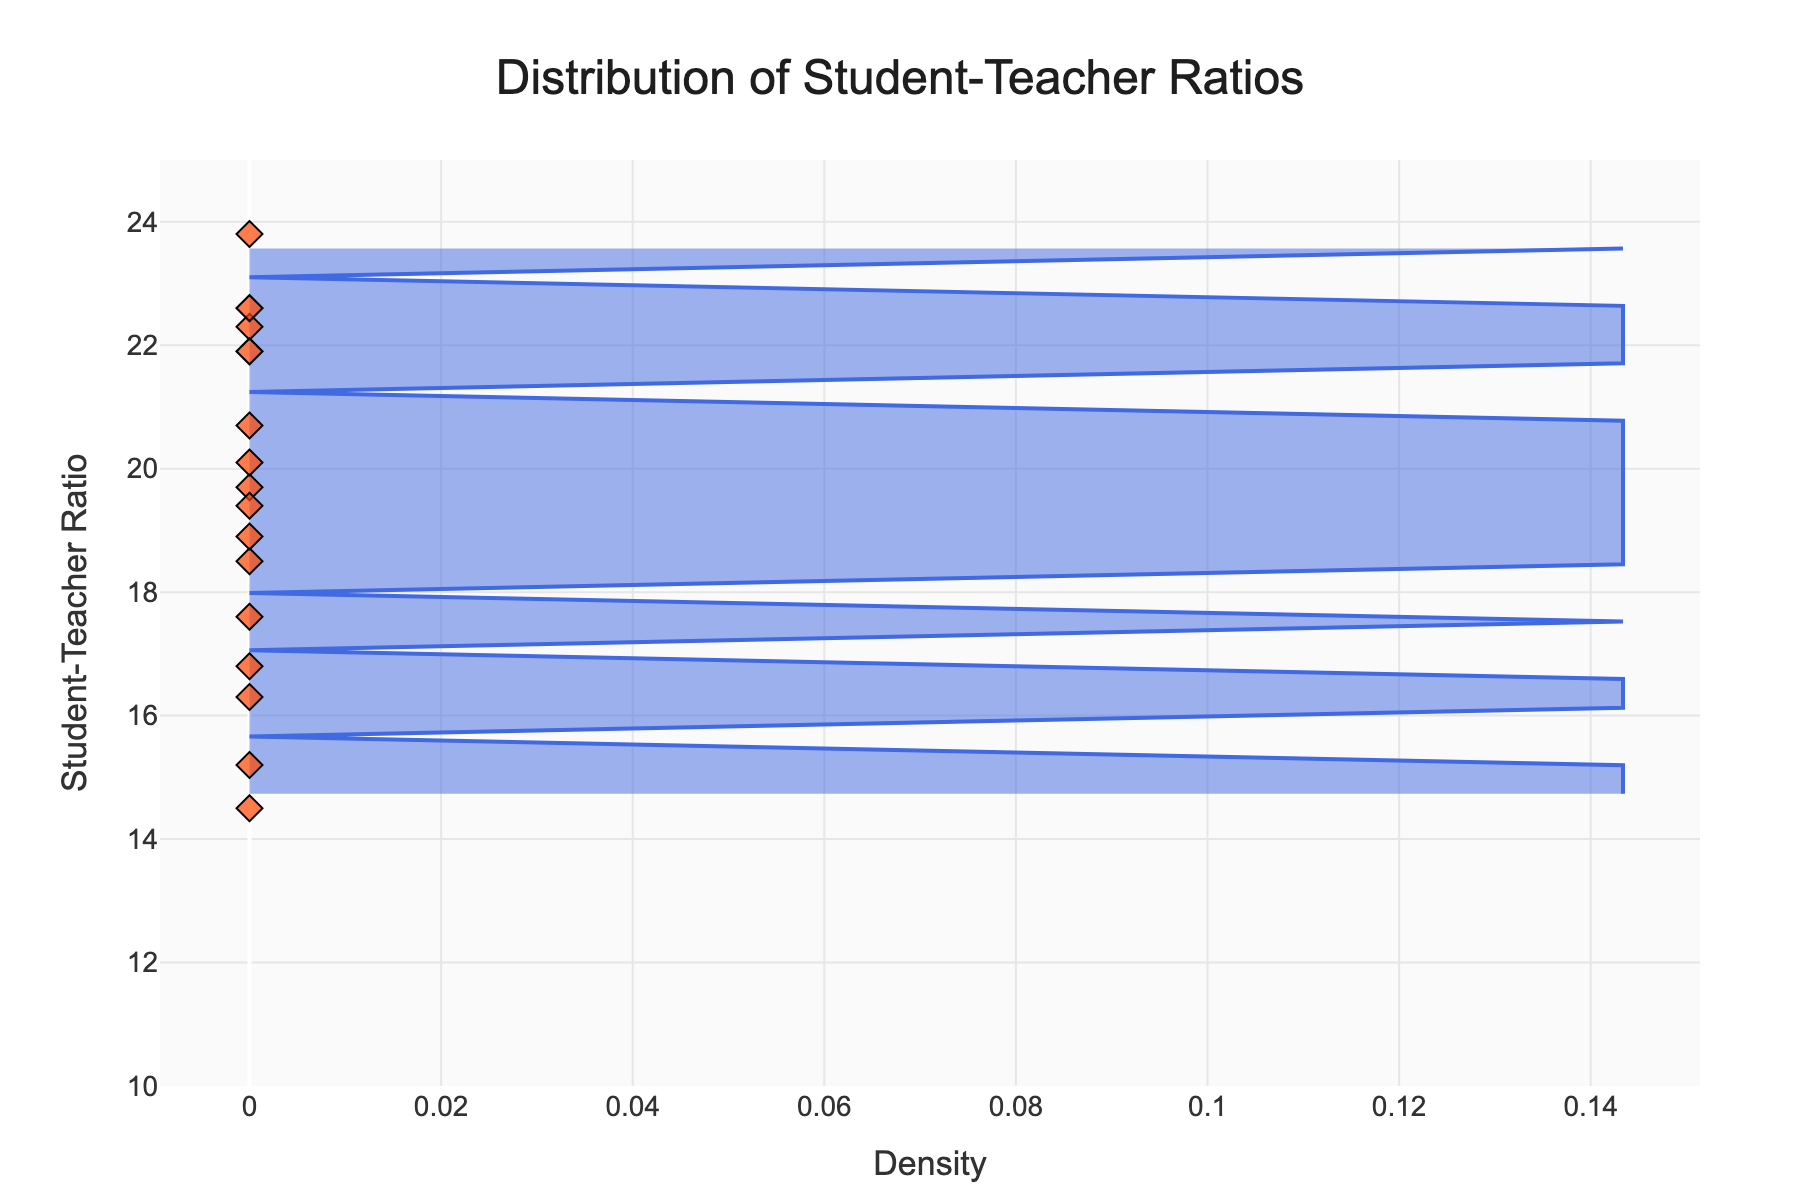What does the title of the plot indicate? The title 'Distribution of Student-Teacher Ratios' suggests that the plot is showing how student-teacher ratios are spread across various schools.
Answer: Distribution of Student-Teacher Ratios What is the student-teacher ratio range visible on the y-axis? The y-axis range is clearly marked between 10 and 25, indicating the spread of student-teacher ratios being visualized.
Answer: 10 to 25 Which school has the highest student-teacher ratio? Referring to individual school markers, Central High, which peaks at 23.8 on the y-axis, has the highest ratio.
Answer: Central High On average, do the elementary schools have a higher or lower student-teacher ratio compared to high schools? By averaging the ratios of elementary schools (Oakwood, Washington, Maple Grove, Hillcrest, Fairview) and high schools (Riverside, Jefferson, Central, Pioneer), we get (18.5+19.7+17.6+18.9+20.7)/5 = 19.08 and (22.3+21.9+23.8+22.6)/4 = 22.65 respectively. Thus, elementary schools have a lower average ratio compared to high schools.
Answer: Lower Which school is represented by the lowest student-teacher ratio? The lowest student-teacher ratio marker on the scatter plot aligns with Westfield Preparatory at a ratio of 14.5.
Answer: Westfield Preparatory What color represents the individual schools on the plot? The scatter plot symbols representing individual schools are colored in a bright orange hue.
Answer: Orange What is the purpose of the shaded area in the plot? The shaded area represents the density estimate, which shows where student-teacher ratios are most commonly found across the schools.
Answer: Density estimate What is the student-teacher ratio for Lincoln Academy? The plot shows individual schools with their corresponding ratios, and the ratio for Lincoln Academy is marked at 15.2.
Answer: 15.2 How many schools have a student-teacher ratio higher than 20? By counting the markers above the 20 ratio line on the y-axis: Riverside High, Jefferson High, Evergreen Middle School, Central High, Fairview Elementary, and Pioneer High, there are 6 schools.
Answer: 6 Does any school have an exact student-teacher ratio of 20? On close inspection of the scatter plots, Evergreen Middle School has an exact ratio of 20.1, none exactly 20.0.
Answer: No, closest is 20.1 